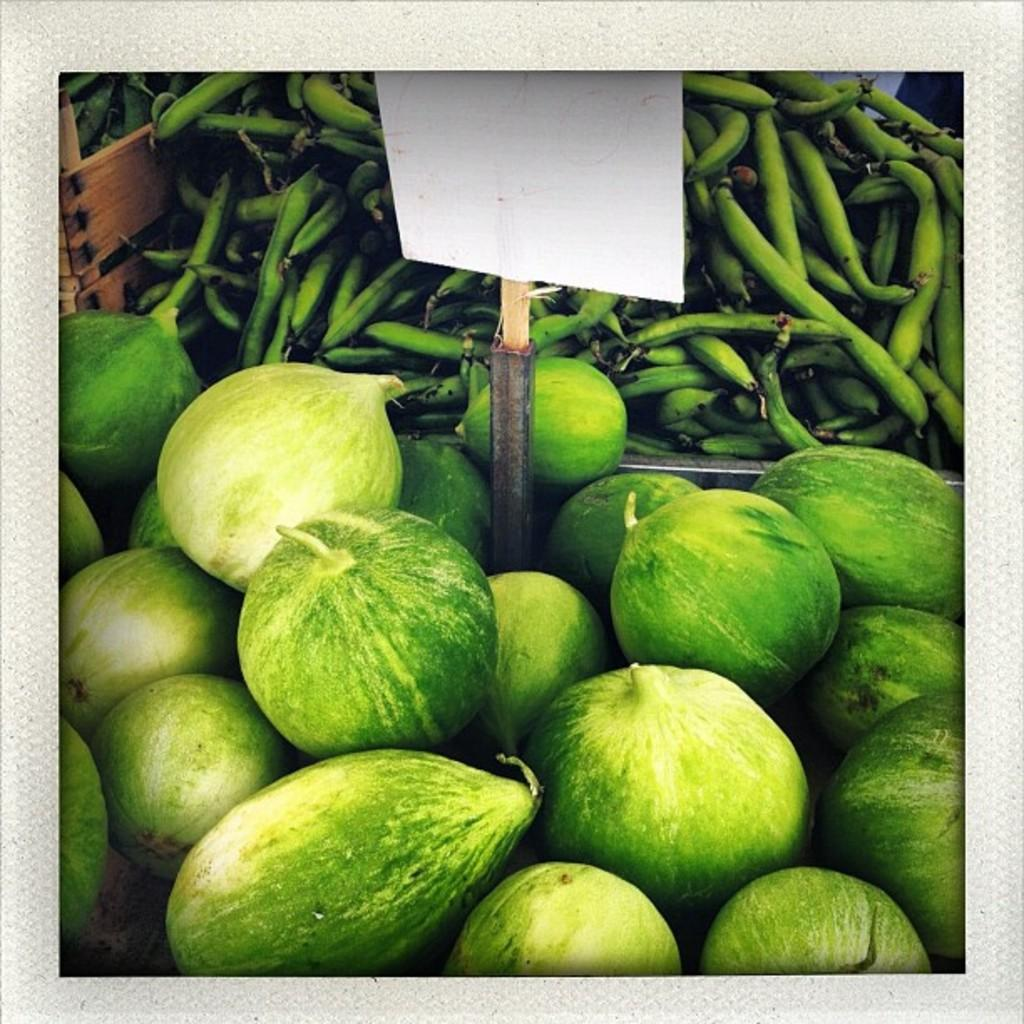What type of vegetables are present in the image? There are cucumbers and beans in the image. What else can be seen in the image besides the vegetables? There is a board in the image. What type of clouds can be seen in the image? There are no clouds present in the image; it only features cucumbers, beans, and a board. 